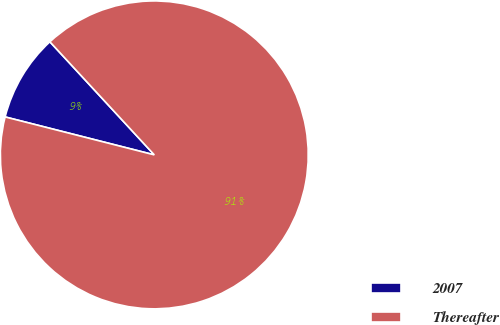Convert chart. <chart><loc_0><loc_0><loc_500><loc_500><pie_chart><fcel>2007<fcel>Thereafter<nl><fcel>9.17%<fcel>90.83%<nl></chart> 